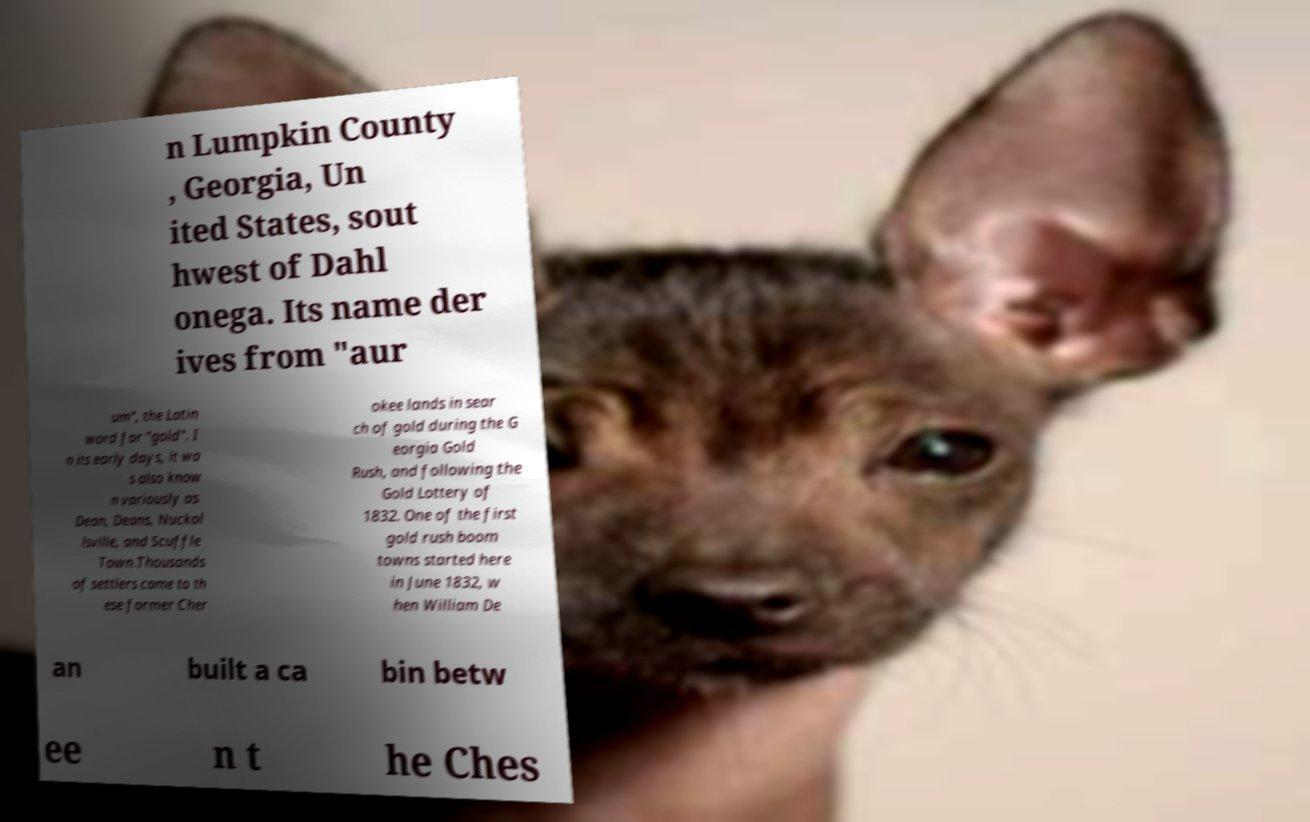Can you read and provide the text displayed in the image?This photo seems to have some interesting text. Can you extract and type it out for me? n Lumpkin County , Georgia, Un ited States, sout hwest of Dahl onega. Its name der ives from "aur um", the Latin word for "gold". I n its early days, it wa s also know n variously as Dean, Deans, Nuckol lsville, and Scuffle Town.Thousands of settlers came to th ese former Cher okee lands in sear ch of gold during the G eorgia Gold Rush, and following the Gold Lottery of 1832. One of the first gold rush boom towns started here in June 1832, w hen William De an built a ca bin betw ee n t he Ches 